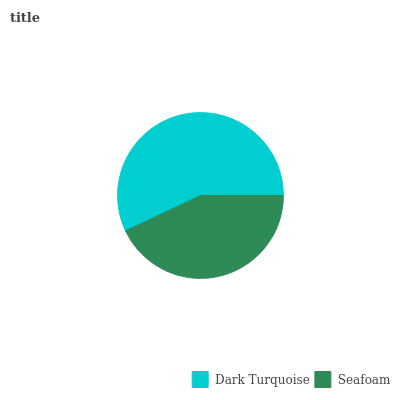Is Seafoam the minimum?
Answer yes or no. Yes. Is Dark Turquoise the maximum?
Answer yes or no. Yes. Is Seafoam the maximum?
Answer yes or no. No. Is Dark Turquoise greater than Seafoam?
Answer yes or no. Yes. Is Seafoam less than Dark Turquoise?
Answer yes or no. Yes. Is Seafoam greater than Dark Turquoise?
Answer yes or no. No. Is Dark Turquoise less than Seafoam?
Answer yes or no. No. Is Dark Turquoise the high median?
Answer yes or no. Yes. Is Seafoam the low median?
Answer yes or no. Yes. Is Seafoam the high median?
Answer yes or no. No. Is Dark Turquoise the low median?
Answer yes or no. No. 